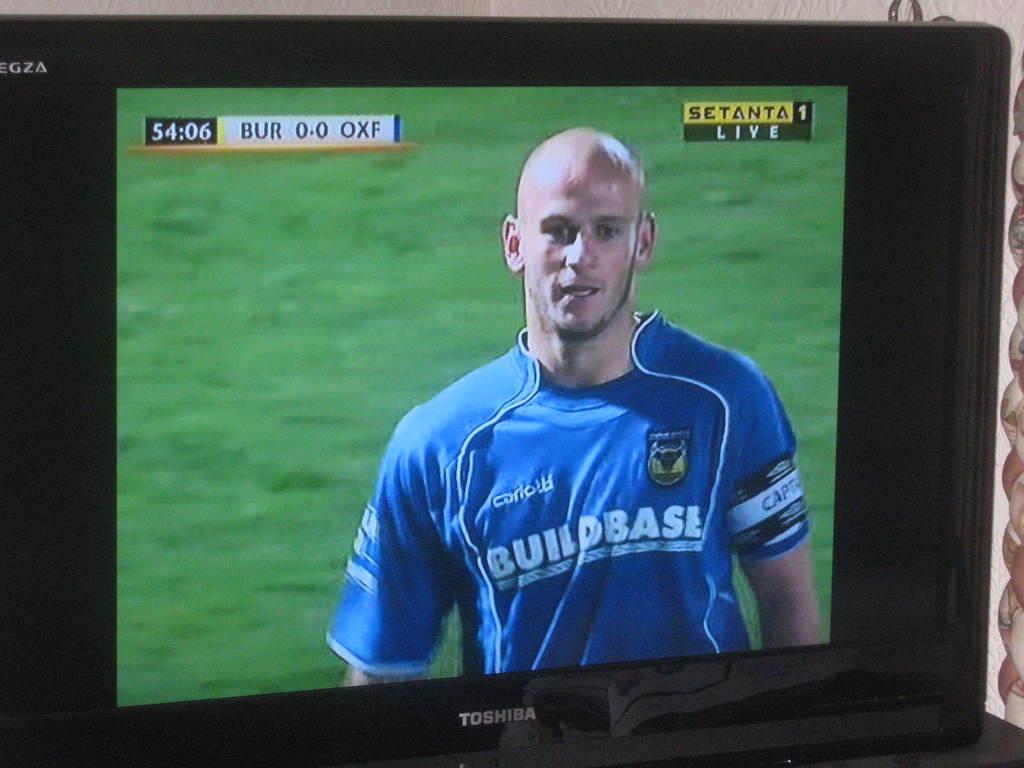What is the timer at?
Offer a terse response. 54:06. What is written on the athlete's jersey?
Give a very brief answer. Buildbase. 